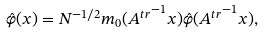Convert formula to latex. <formula><loc_0><loc_0><loc_500><loc_500>\hat { \varphi } ( x ) = N ^ { - 1 / 2 } m _ { 0 } ( { A ^ { t r } } ^ { - 1 } x ) \hat { \varphi } ( { A ^ { t r } } ^ { - 1 } x ) ,</formula> 